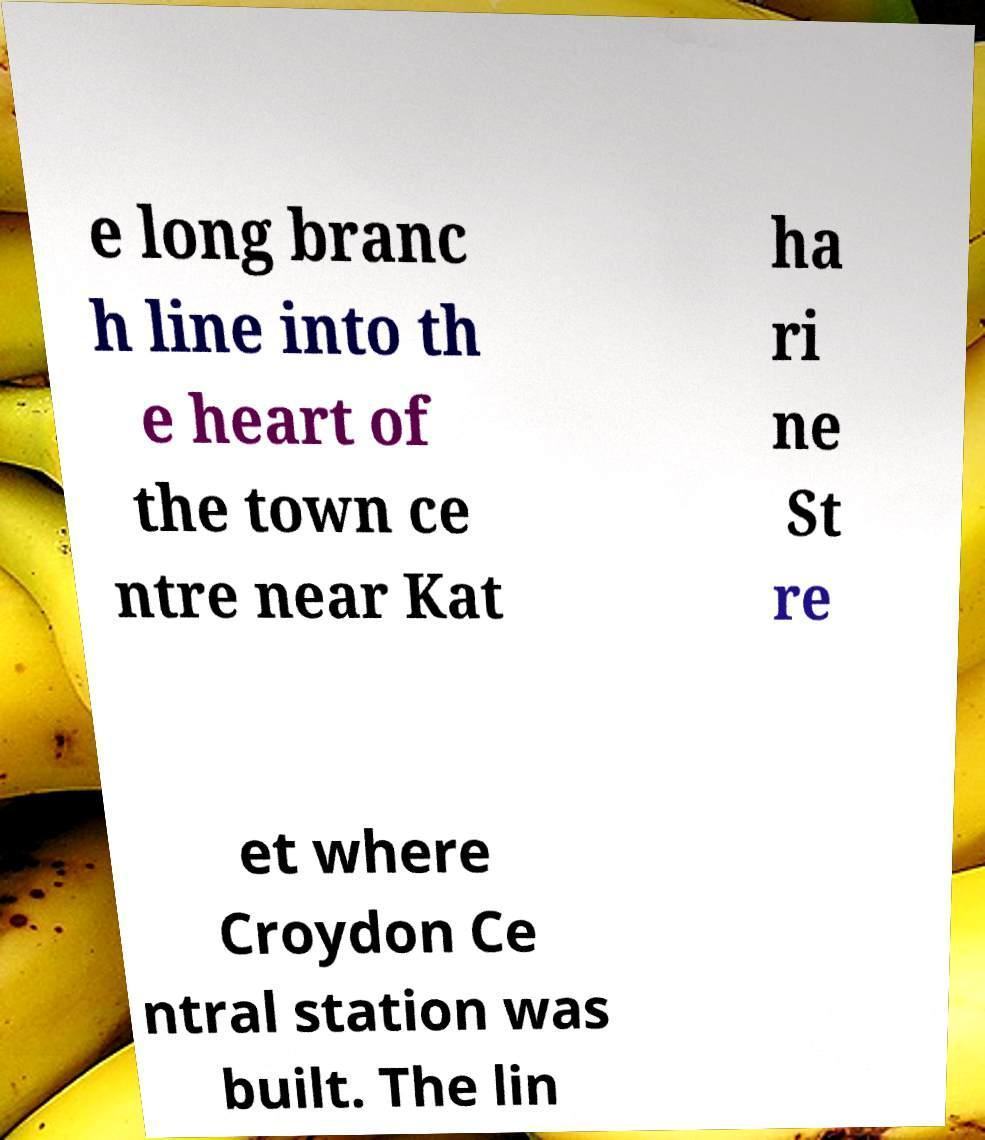Please identify and transcribe the text found in this image. e long branc h line into th e heart of the town ce ntre near Kat ha ri ne St re et where Croydon Ce ntral station was built. The lin 